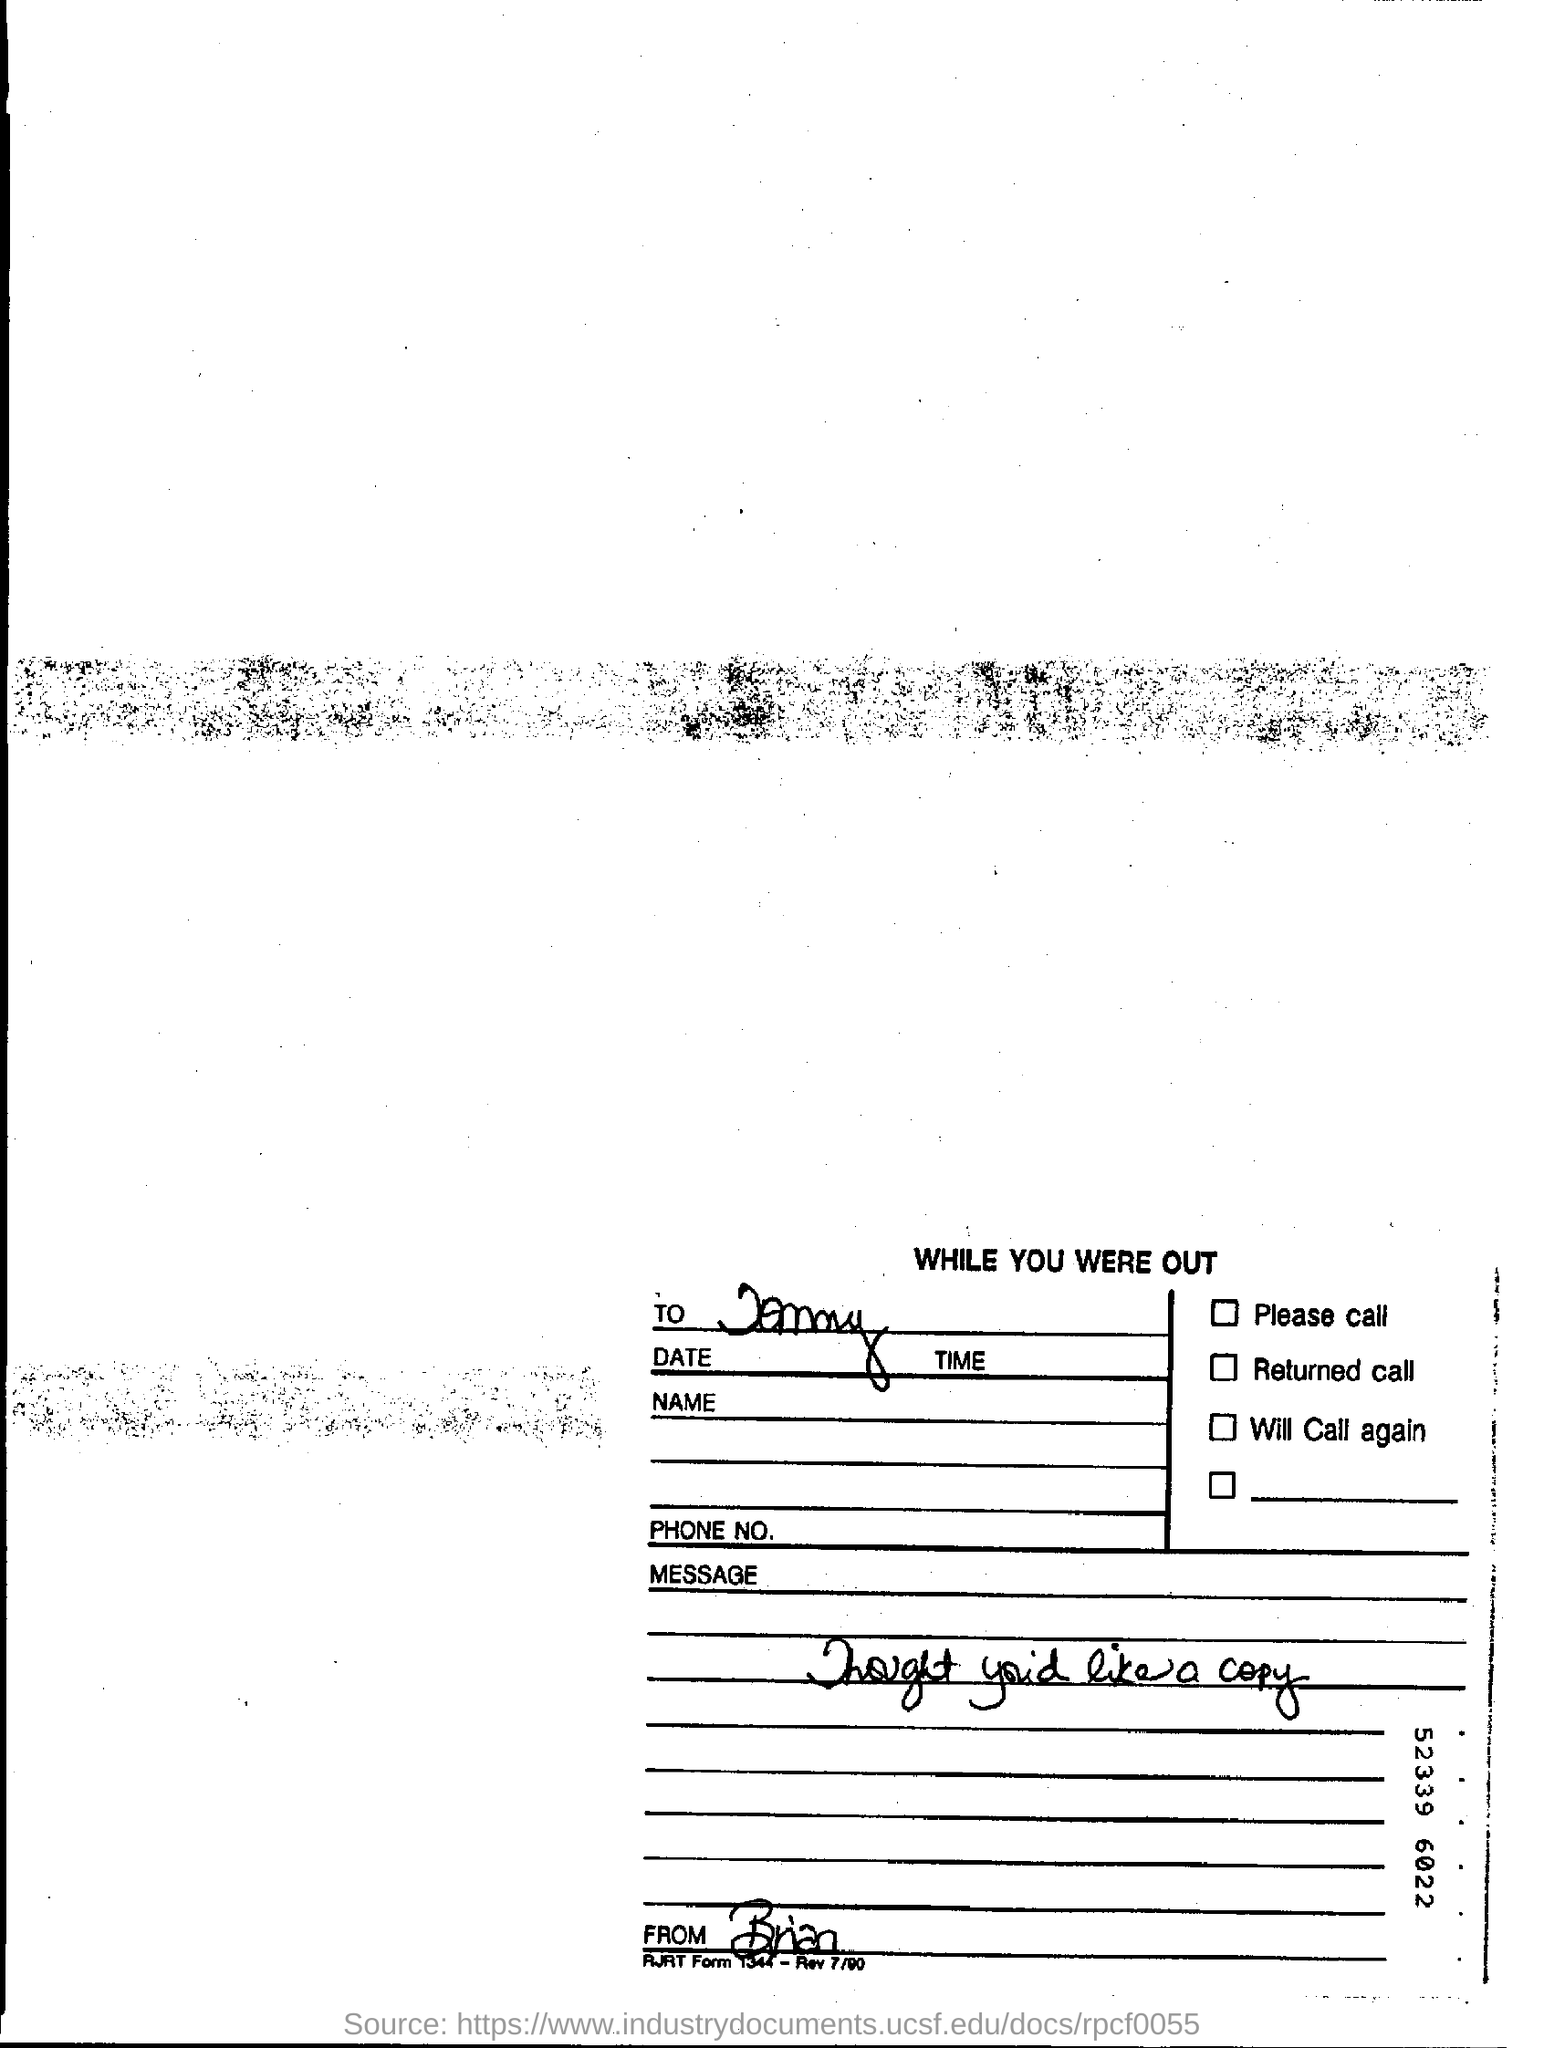Who wrote this letter
Your answer should be compact. Brian. 